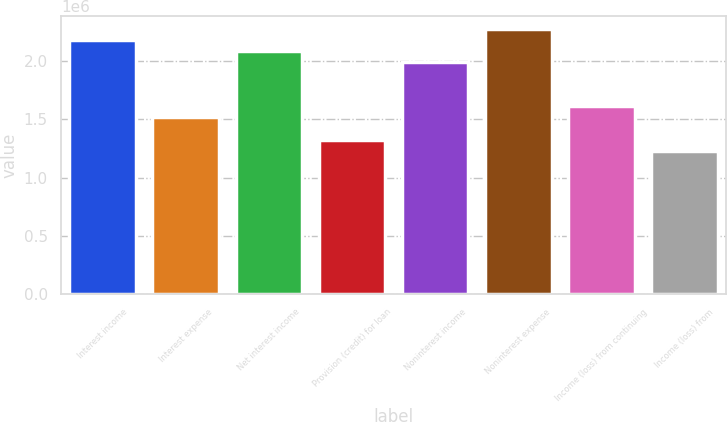Convert chart to OTSL. <chart><loc_0><loc_0><loc_500><loc_500><bar_chart><fcel>Interest income<fcel>Interest expense<fcel>Net interest income<fcel>Provision (credit) for loan<fcel>Noninterest income<fcel>Noninterest expense<fcel>Income (loss) from continuing<fcel>Income (loss) from<nl><fcel>2.1806e+06<fcel>1.51694e+06<fcel>2.08579e+06<fcel>1.32732e+06<fcel>1.99098e+06<fcel>2.27541e+06<fcel>1.61175e+06<fcel>1.23251e+06<nl></chart> 